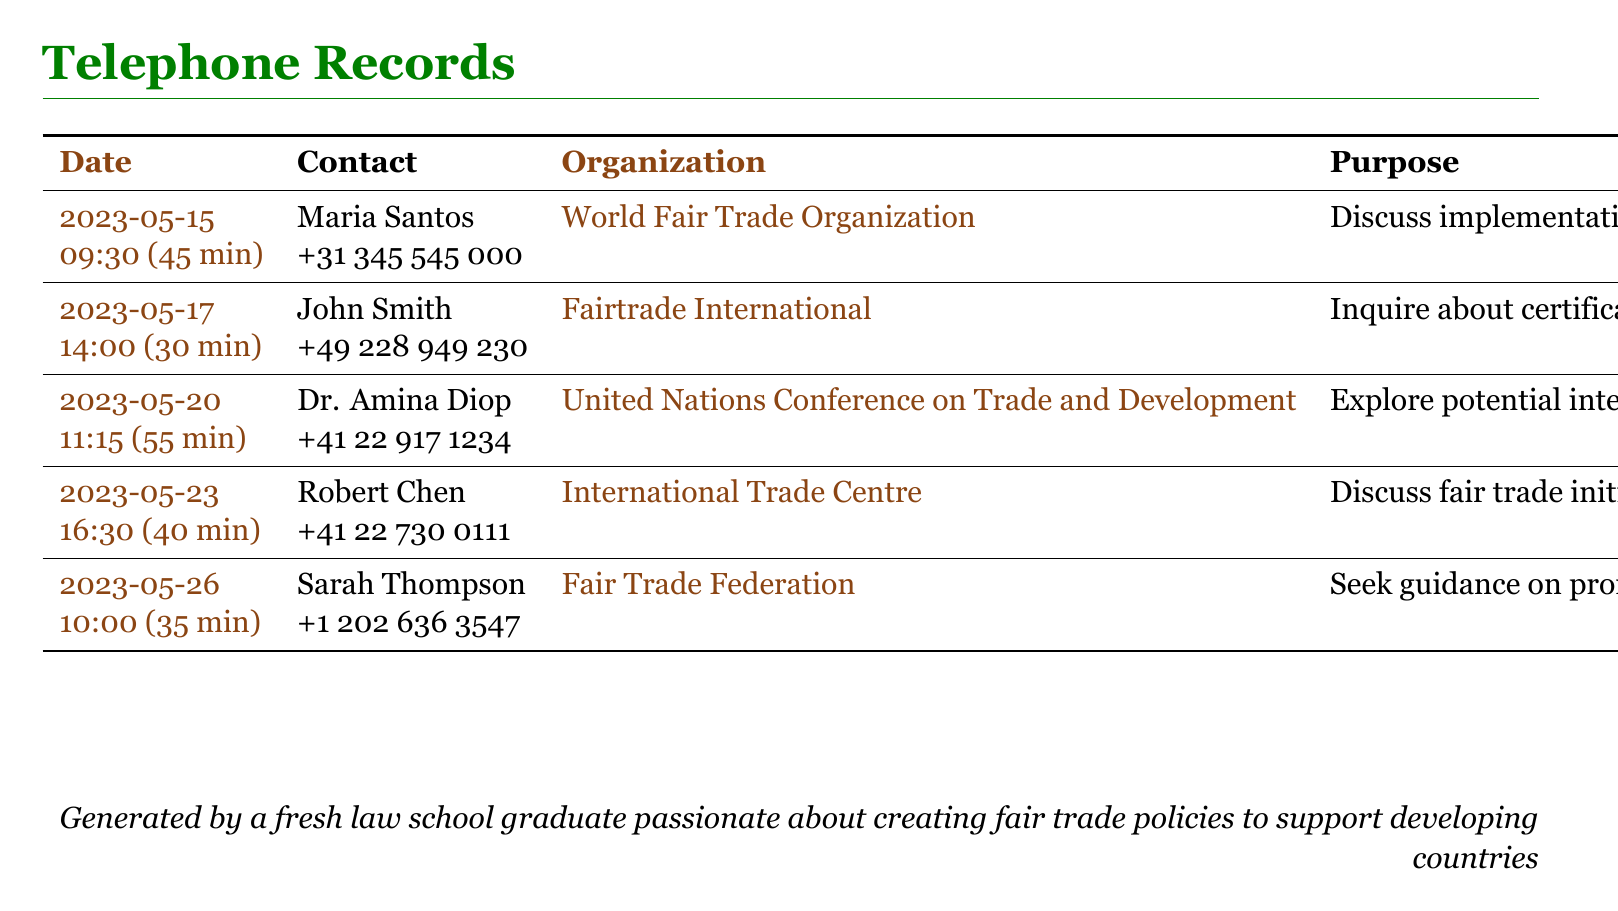What is the date of the call with Maria Santos? The date of the call is specified in the table under the 'Date' column for Maria Santos.
Answer: 2023-05-15 How long was the call with John Smith? The duration of the call is indicated in the table next to John's name, which shows the length of the conversation.
Answer: 30 min Who was contacted about fair trade policies in the coffee industry? The name of the contact for the coffee industry discussion is listed in the table.
Answer: Maria Santos How many minutes was the call with Dr. Amina Diop? The length of the call with Dr. Amina Diop is presented in the table under the duration column.
Answer: 55 min What organization does Robert Chen represent? The organization associated with Robert Chen is noted in the table under the 'Organization' column.
Answer: International Trade Centre What is the main purpose of the call with Sarah Thompson? The purpose of the call is defined in the table under the 'Purpose' column for Sarah Thompson.
Answer: Promoting fair trade policies in law school curriculum Which contact has the longest call duration? To determine this, one must compare the call durations provided for each individual in the document.
Answer: Dr. Amina Diop What is the phone number for Fairtrade International? The phone number for this organization is located in the table next to John Smith's details.
Answer: +49 228 949 230 On what date was the call about fair trade initiatives in the textile industry? The date for this call is found under the 'Date' column related to Robert Chen in the table.
Answer: 2023-05-23 